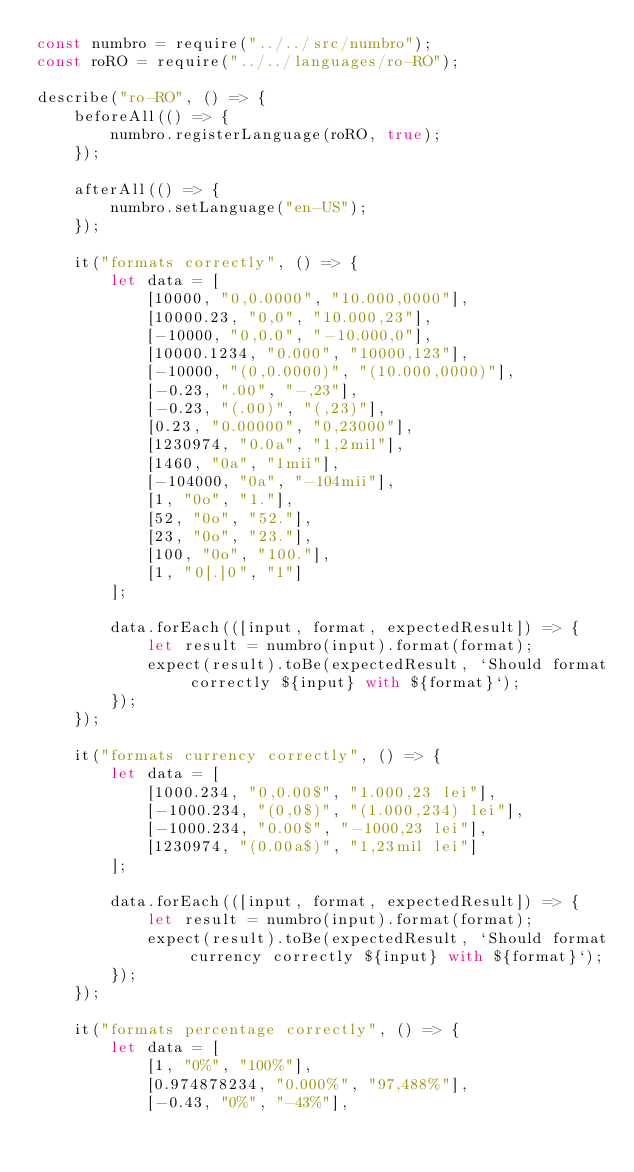<code> <loc_0><loc_0><loc_500><loc_500><_JavaScript_>const numbro = require("../../src/numbro");
const roRO = require("../../languages/ro-RO");

describe("ro-RO", () => {
    beforeAll(() => {
        numbro.registerLanguage(roRO, true);
    });

    afterAll(() => {
        numbro.setLanguage("en-US");
    });

    it("formats correctly", () => {
        let data = [
            [10000, "0,0.0000", "10.000,0000"],
            [10000.23, "0,0", "10.000,23"],
            [-10000, "0,0.0", "-10.000,0"],
            [10000.1234, "0.000", "10000,123"],
            [-10000, "(0,0.0000)", "(10.000,0000)"],
            [-0.23, ".00", "-,23"],
            [-0.23, "(.00)", "(,23)"],
            [0.23, "0.00000", "0,23000"],
            [1230974, "0.0a", "1,2mil"],
            [1460, "0a", "1mii"],
            [-104000, "0a", "-104mii"],
            [1, "0o", "1."],
            [52, "0o", "52."],
            [23, "0o", "23."],
            [100, "0o", "100."],
            [1, "0[.]0", "1"]
        ];

        data.forEach(([input, format, expectedResult]) => {
            let result = numbro(input).format(format);
            expect(result).toBe(expectedResult, `Should format correctly ${input} with ${format}`);
        });
    });

    it("formats currency correctly", () => {
        let data = [
            [1000.234, "0,0.00$", "1.000,23 lei"],
            [-1000.234, "(0,0$)", "(1.000,234) lei"],
            [-1000.234, "0.00$", "-1000,23 lei"],
            [1230974, "(0.00a$)", "1,23mil lei"]
        ];

        data.forEach(([input, format, expectedResult]) => {
            let result = numbro(input).format(format);
            expect(result).toBe(expectedResult, `Should format currency correctly ${input} with ${format}`);
        });
    });

    it("formats percentage correctly", () => {
        let data = [
            [1, "0%", "100%"],
            [0.974878234, "0.000%", "97,488%"],
            [-0.43, "0%", "-43%"],</code> 